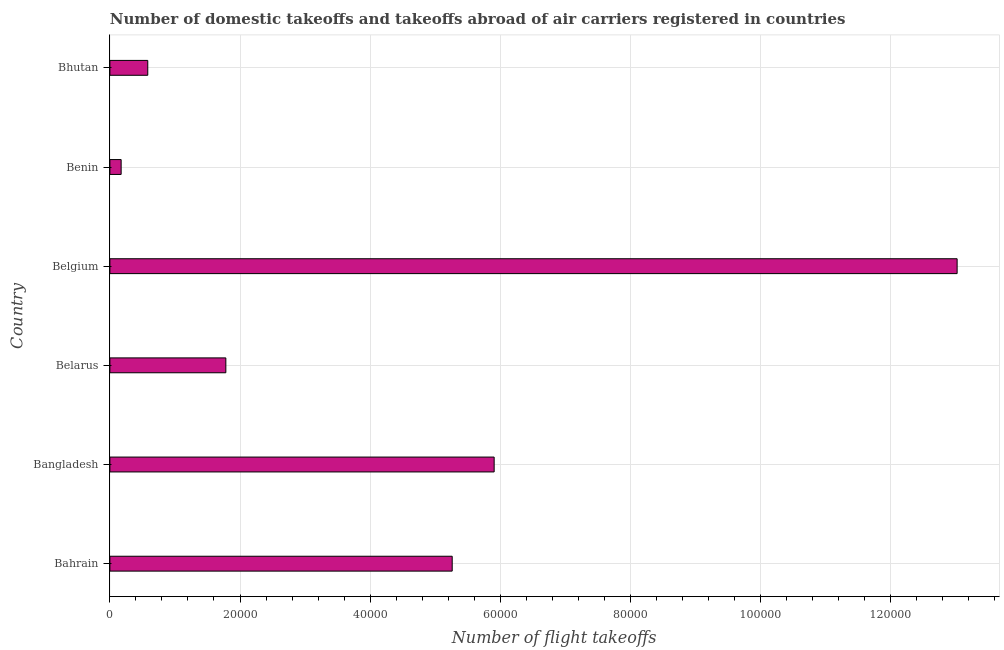Does the graph contain grids?
Your answer should be compact. Yes. What is the title of the graph?
Give a very brief answer. Number of domestic takeoffs and takeoffs abroad of air carriers registered in countries. What is the label or title of the X-axis?
Offer a terse response. Number of flight takeoffs. What is the number of flight takeoffs in Bahrain?
Keep it short and to the point. 5.26e+04. Across all countries, what is the maximum number of flight takeoffs?
Provide a short and direct response. 1.30e+05. Across all countries, what is the minimum number of flight takeoffs?
Keep it short and to the point. 1730. In which country was the number of flight takeoffs minimum?
Provide a short and direct response. Benin. What is the sum of the number of flight takeoffs?
Offer a very short reply. 2.67e+05. What is the difference between the number of flight takeoffs in Bangladesh and Belarus?
Your answer should be compact. 4.12e+04. What is the average number of flight takeoffs per country?
Provide a succinct answer. 4.45e+04. What is the median number of flight takeoffs?
Keep it short and to the point. 3.52e+04. What is the ratio of the number of flight takeoffs in Benin to that in Bhutan?
Give a very brief answer. 0.3. Is the difference between the number of flight takeoffs in Bahrain and Bhutan greater than the difference between any two countries?
Provide a succinct answer. No. What is the difference between the highest and the second highest number of flight takeoffs?
Your response must be concise. 7.12e+04. What is the difference between the highest and the lowest number of flight takeoffs?
Offer a terse response. 1.29e+05. In how many countries, is the number of flight takeoffs greater than the average number of flight takeoffs taken over all countries?
Your response must be concise. 3. Are all the bars in the graph horizontal?
Keep it short and to the point. Yes. How many countries are there in the graph?
Keep it short and to the point. 6. What is the Number of flight takeoffs in Bahrain?
Keep it short and to the point. 5.26e+04. What is the Number of flight takeoffs in Bangladesh?
Provide a short and direct response. 5.91e+04. What is the Number of flight takeoffs of Belarus?
Provide a short and direct response. 1.78e+04. What is the Number of flight takeoffs in Belgium?
Offer a very short reply. 1.30e+05. What is the Number of flight takeoffs in Benin?
Your answer should be compact. 1730. What is the Number of flight takeoffs in Bhutan?
Offer a very short reply. 5822.49. What is the difference between the Number of flight takeoffs in Bahrain and Bangladesh?
Your answer should be compact. -6447.91. What is the difference between the Number of flight takeoffs in Bahrain and Belarus?
Keep it short and to the point. 3.48e+04. What is the difference between the Number of flight takeoffs in Bahrain and Belgium?
Your answer should be compact. -7.76e+04. What is the difference between the Number of flight takeoffs in Bahrain and Benin?
Ensure brevity in your answer.  5.09e+04. What is the difference between the Number of flight takeoffs in Bahrain and Bhutan?
Provide a succinct answer. 4.68e+04. What is the difference between the Number of flight takeoffs in Bangladesh and Belarus?
Give a very brief answer. 4.12e+04. What is the difference between the Number of flight takeoffs in Bangladesh and Belgium?
Your answer should be very brief. -7.12e+04. What is the difference between the Number of flight takeoffs in Bangladesh and Benin?
Give a very brief answer. 5.73e+04. What is the difference between the Number of flight takeoffs in Bangladesh and Bhutan?
Keep it short and to the point. 5.32e+04. What is the difference between the Number of flight takeoffs in Belarus and Belgium?
Give a very brief answer. -1.12e+05. What is the difference between the Number of flight takeoffs in Belarus and Benin?
Offer a very short reply. 1.61e+04. What is the difference between the Number of flight takeoffs in Belarus and Bhutan?
Make the answer very short. 1.20e+04. What is the difference between the Number of flight takeoffs in Belgium and Benin?
Your answer should be compact. 1.29e+05. What is the difference between the Number of flight takeoffs in Belgium and Bhutan?
Your answer should be compact. 1.24e+05. What is the difference between the Number of flight takeoffs in Benin and Bhutan?
Your response must be concise. -4092.49. What is the ratio of the Number of flight takeoffs in Bahrain to that in Bangladesh?
Provide a short and direct response. 0.89. What is the ratio of the Number of flight takeoffs in Bahrain to that in Belarus?
Offer a very short reply. 2.95. What is the ratio of the Number of flight takeoffs in Bahrain to that in Belgium?
Offer a very short reply. 0.4. What is the ratio of the Number of flight takeoffs in Bahrain to that in Benin?
Provide a succinct answer. 30.42. What is the ratio of the Number of flight takeoffs in Bahrain to that in Bhutan?
Offer a terse response. 9.04. What is the ratio of the Number of flight takeoffs in Bangladesh to that in Belarus?
Keep it short and to the point. 3.31. What is the ratio of the Number of flight takeoffs in Bangladesh to that in Belgium?
Provide a short and direct response. 0.45. What is the ratio of the Number of flight takeoffs in Bangladesh to that in Benin?
Keep it short and to the point. 34.14. What is the ratio of the Number of flight takeoffs in Bangladesh to that in Bhutan?
Your answer should be very brief. 10.14. What is the ratio of the Number of flight takeoffs in Belarus to that in Belgium?
Give a very brief answer. 0.14. What is the ratio of the Number of flight takeoffs in Belarus to that in Benin?
Your response must be concise. 10.3. What is the ratio of the Number of flight takeoffs in Belarus to that in Bhutan?
Provide a short and direct response. 3.06. What is the ratio of the Number of flight takeoffs in Belgium to that in Benin?
Provide a short and direct response. 75.28. What is the ratio of the Number of flight takeoffs in Belgium to that in Bhutan?
Your response must be concise. 22.37. What is the ratio of the Number of flight takeoffs in Benin to that in Bhutan?
Give a very brief answer. 0.3. 